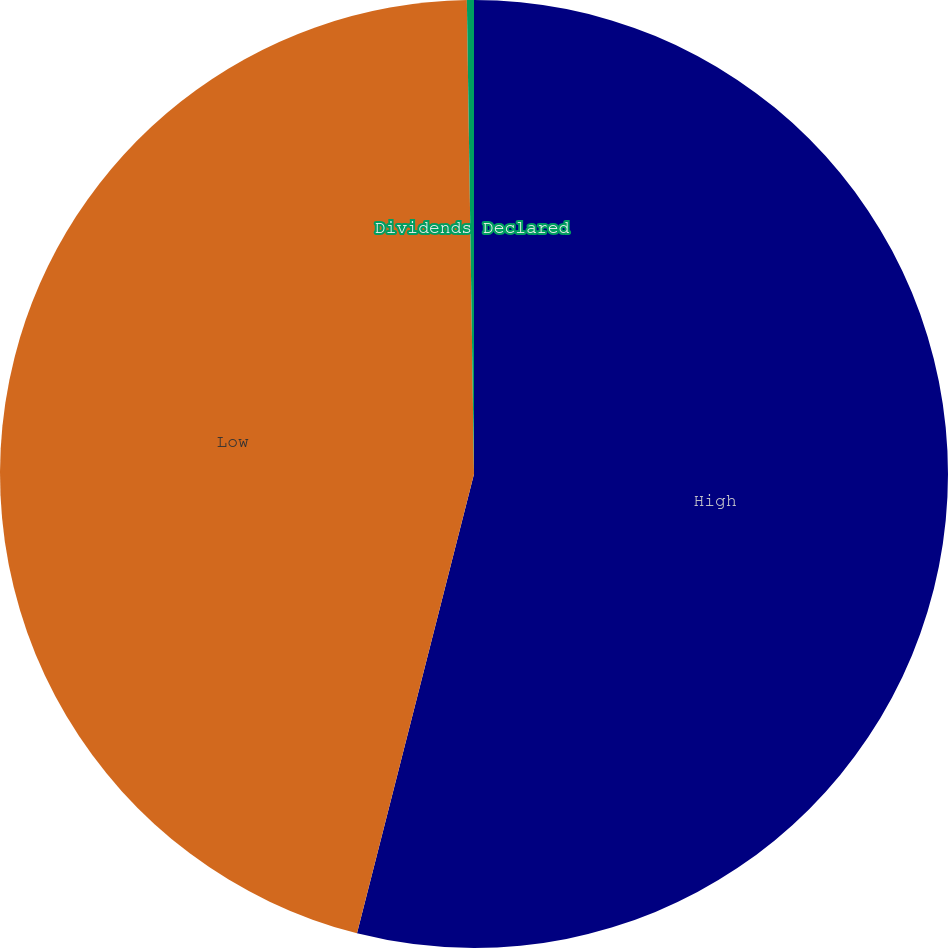Convert chart to OTSL. <chart><loc_0><loc_0><loc_500><loc_500><pie_chart><fcel>High<fcel>Low<fcel>Dividends Declared<nl><fcel>53.97%<fcel>45.79%<fcel>0.24%<nl></chart> 